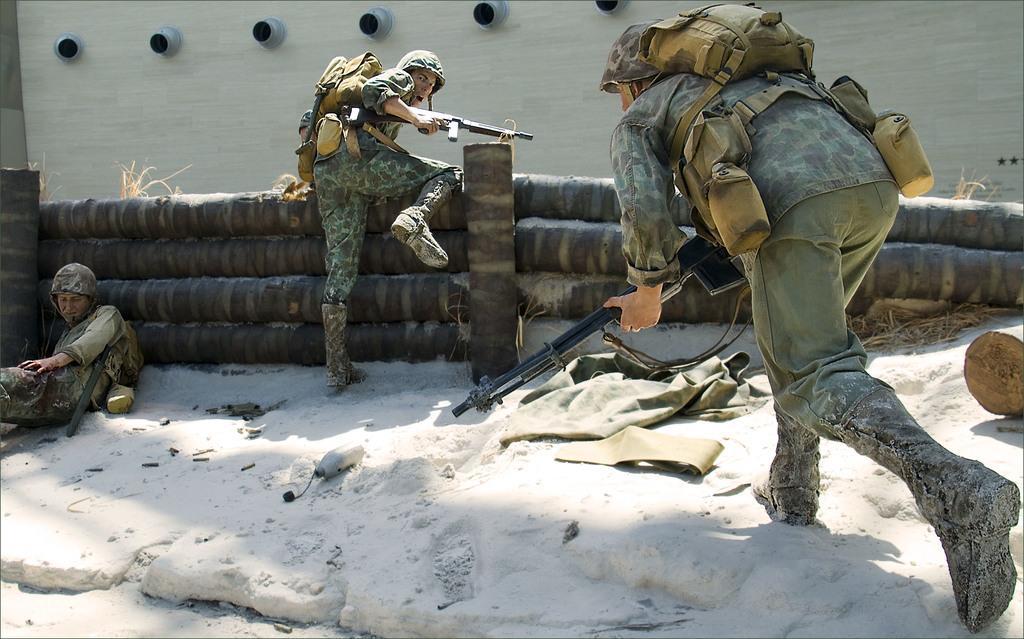Describe this image in one or two sentences. In this picture, we see three military people. Among them, two are holding guns in their hands and they are even wearing backpacks. Behind them, we see a wooden fence and behind that, we see a wall which is white in color. At the bottom of the picture, we see ice and a cloth which is in green and brown color. 